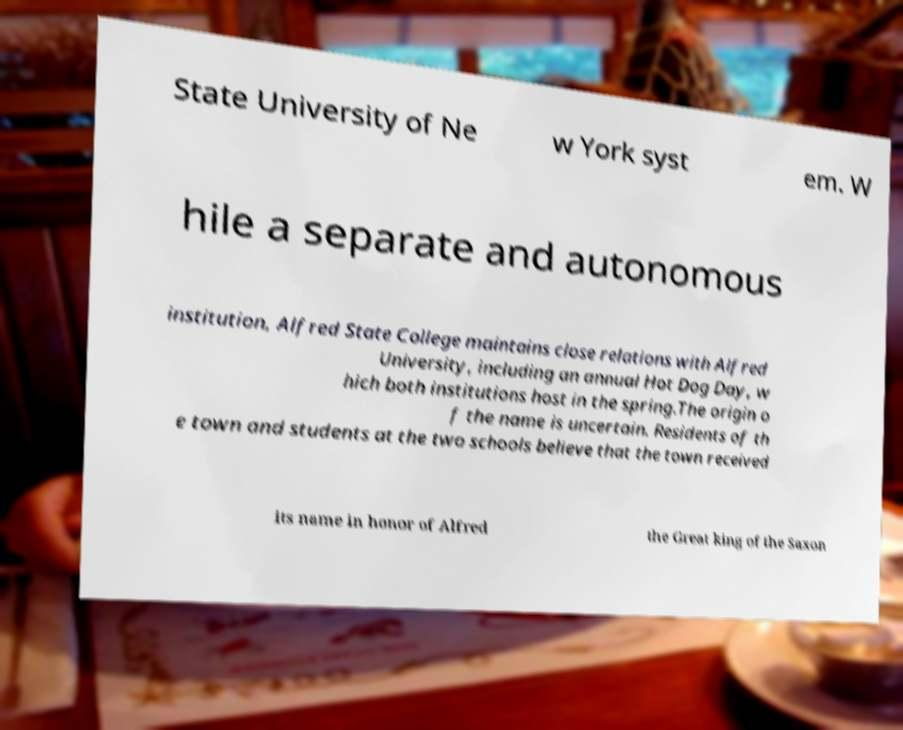Can you read and provide the text displayed in the image?This photo seems to have some interesting text. Can you extract and type it out for me? State University of Ne w York syst em. W hile a separate and autonomous institution, Alfred State College maintains close relations with Alfred University, including an annual Hot Dog Day, w hich both institutions host in the spring.The origin o f the name is uncertain. Residents of th e town and students at the two schools believe that the town received its name in honor of Alfred the Great king of the Saxon 